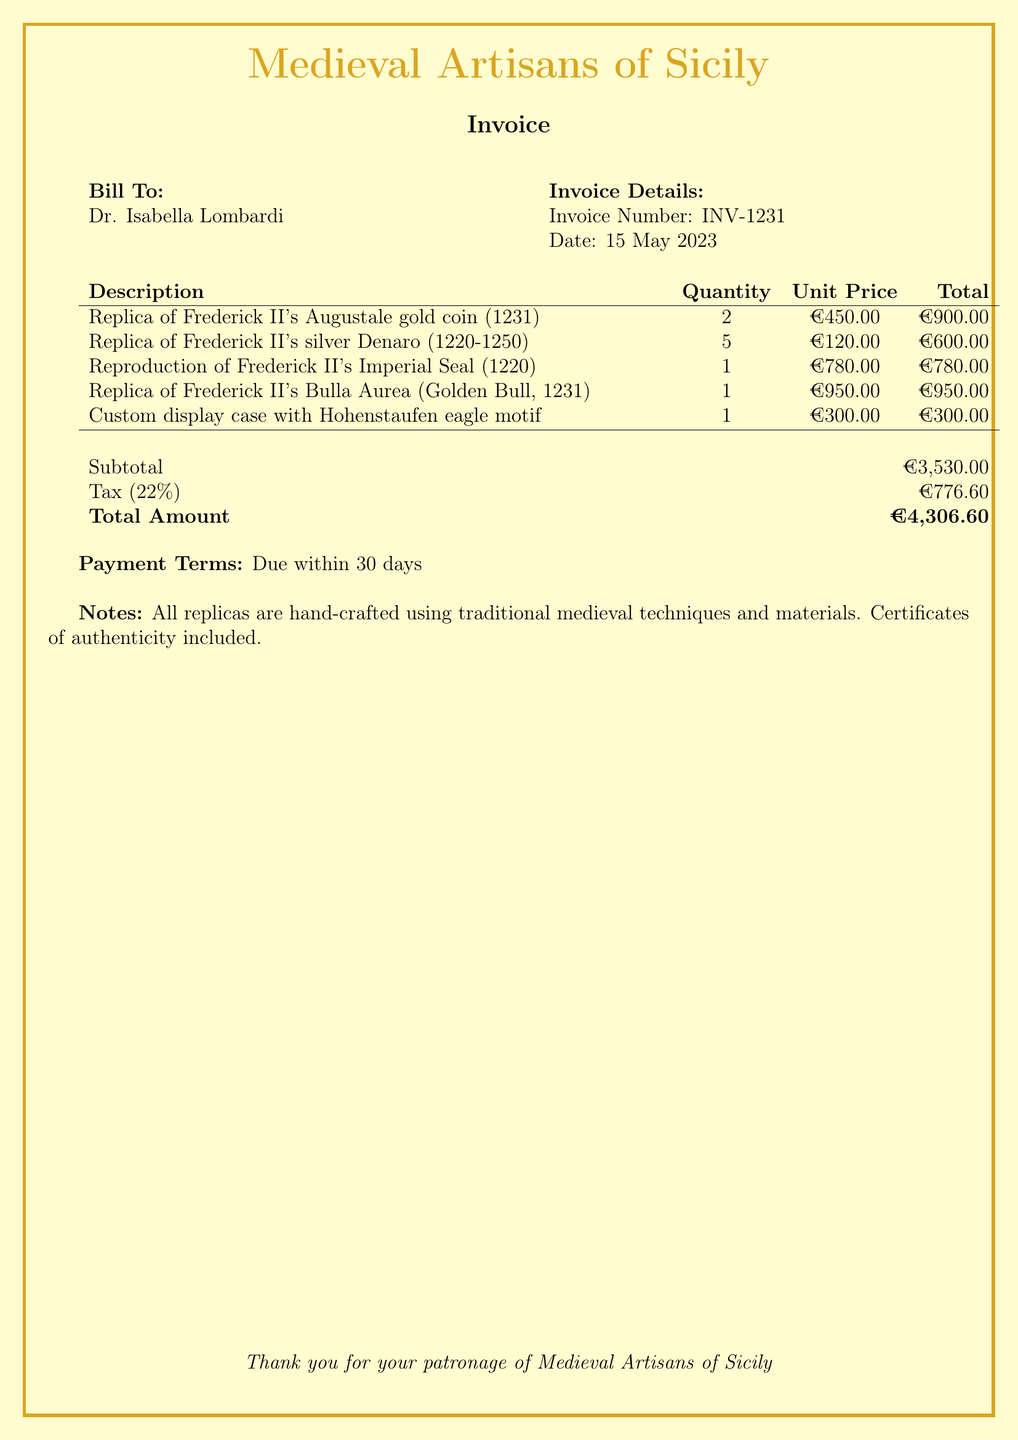What is the invoice number? The invoice number is listed under the invoice details section of the document.
Answer: INV-1231 Who is the bill addressed to? The recipient of the bill is indicated at the top of the document next to "Bill To:".
Answer: Dr. Isabella Lombardi What is the quantity of silver Denaro replicas ordered? The quantity is specified in the table of the document associated with the silver Denaro replicas.
Answer: 5 What is the total amount due? The total amount is found at the bottom of the document's financial summary section.
Answer: €4,306.60 What item has the highest unit price? This can be inferred by examining the unit prices listed in the table.
Answer: Replica of Frederick II's Bulla Aurea What is the tax rate applied in the invoice? The tax rate is mentioned in the calculations section of the document.
Answer: 22% How many different items were ordered? This is determined by counting the distinct items in the description column of the invoice table.
Answer: 5 What is the payment term specified in the document? The payment term is indicated in the payment terms section of the invoice.
Answer: Due within 30 days What is included with each replica? This information is found in the notes section of the document.
Answer: Certificates of authenticity 